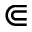<formula> <loc_0><loc_0><loc_500><loc_500>\Subset</formula> 